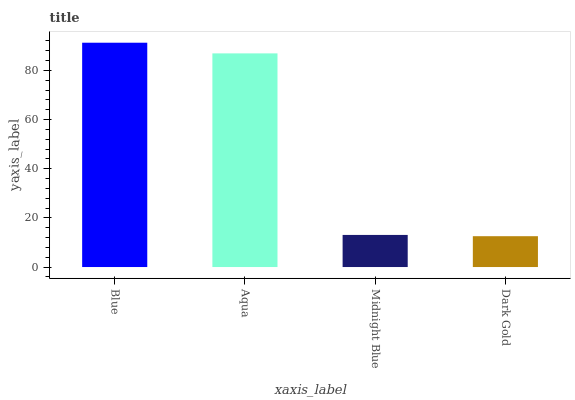Is Aqua the minimum?
Answer yes or no. No. Is Aqua the maximum?
Answer yes or no. No. Is Blue greater than Aqua?
Answer yes or no. Yes. Is Aqua less than Blue?
Answer yes or no. Yes. Is Aqua greater than Blue?
Answer yes or no. No. Is Blue less than Aqua?
Answer yes or no. No. Is Aqua the high median?
Answer yes or no. Yes. Is Midnight Blue the low median?
Answer yes or no. Yes. Is Blue the high median?
Answer yes or no. No. Is Aqua the low median?
Answer yes or no. No. 